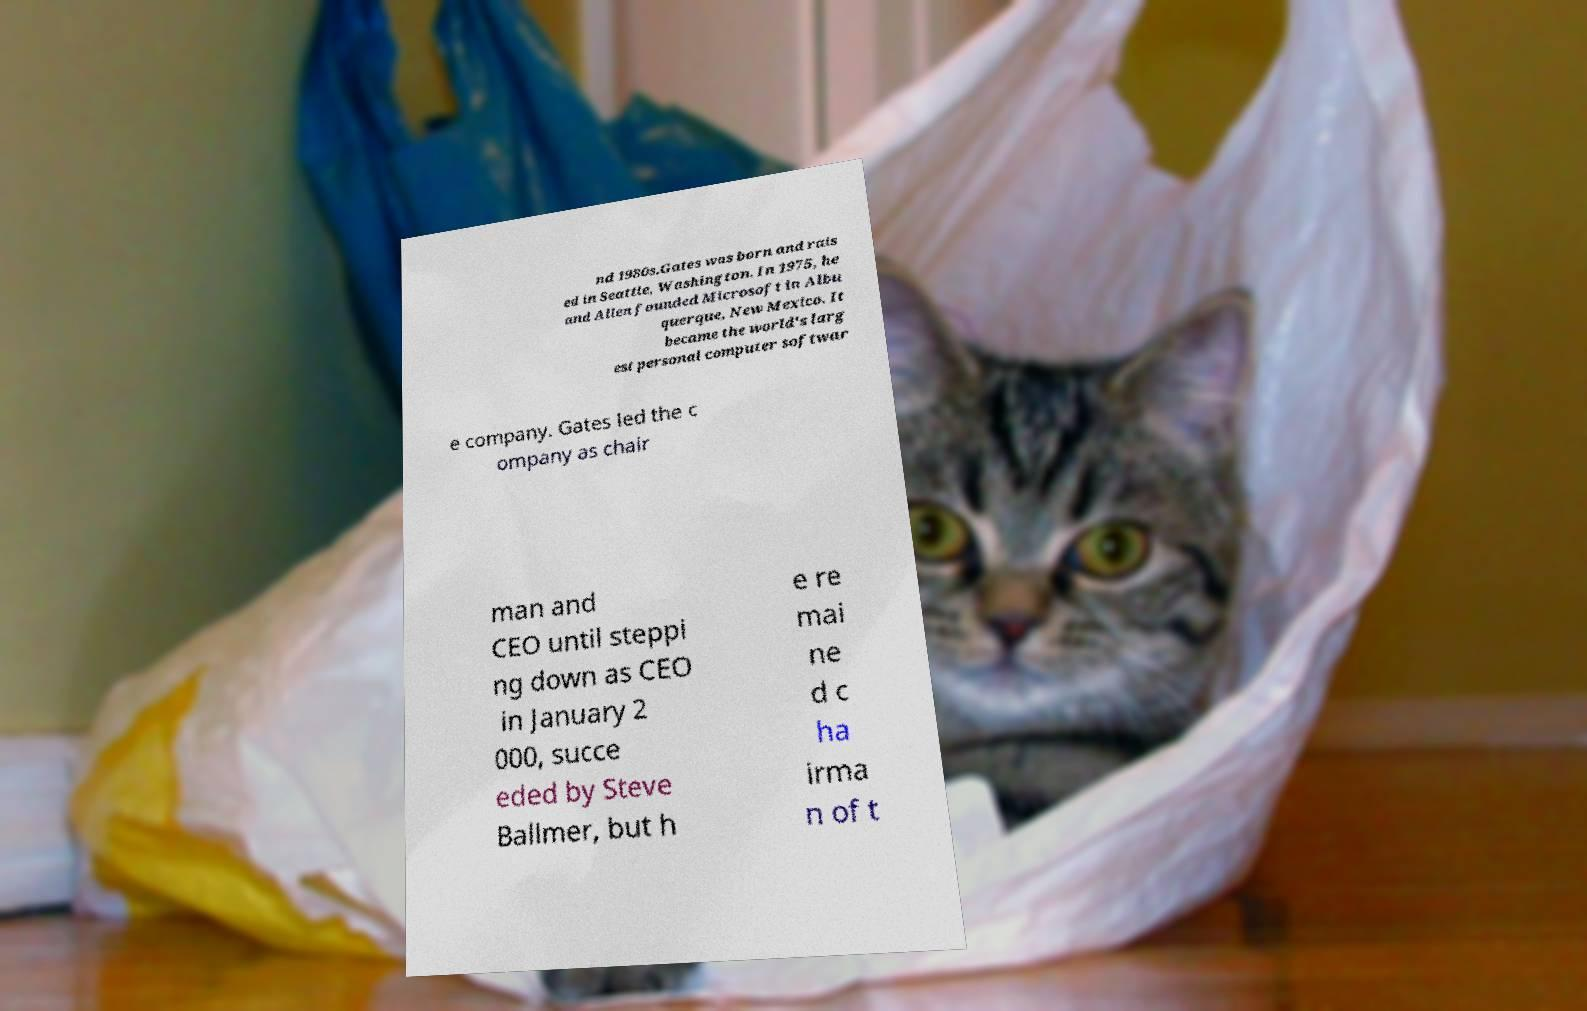Can you accurately transcribe the text from the provided image for me? nd 1980s.Gates was born and rais ed in Seattle, Washington. In 1975, he and Allen founded Microsoft in Albu querque, New Mexico. It became the world's larg est personal computer softwar e company. Gates led the c ompany as chair man and CEO until steppi ng down as CEO in January 2 000, succe eded by Steve Ballmer, but h e re mai ne d c ha irma n of t 